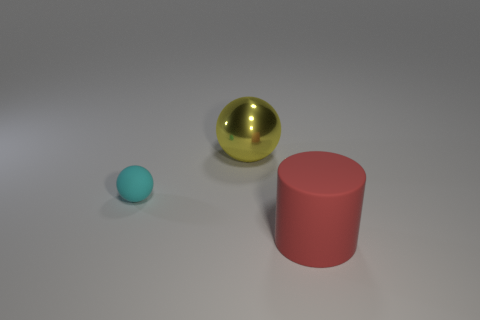Is there anything else that has the same material as the yellow object?
Provide a succinct answer. No. What is the large cylinder made of?
Offer a very short reply. Rubber. What color is the small thing that is the same material as the large red cylinder?
Ensure brevity in your answer.  Cyan. Is the large cylinder made of the same material as the large object that is to the left of the red cylinder?
Keep it short and to the point. No. How many other cyan objects have the same material as the cyan thing?
Provide a short and direct response. 0. What shape is the large object that is left of the large matte cylinder?
Provide a short and direct response. Sphere. Does the ball in front of the yellow sphere have the same material as the thing that is to the right of the large sphere?
Offer a terse response. Yes. Are there any tiny rubber objects of the same shape as the large rubber object?
Ensure brevity in your answer.  No. How many things are big objects that are behind the big matte cylinder or brown shiny cylinders?
Keep it short and to the point. 1. Are there more cyan balls that are in front of the tiny matte object than yellow balls in front of the yellow shiny ball?
Offer a terse response. No. 